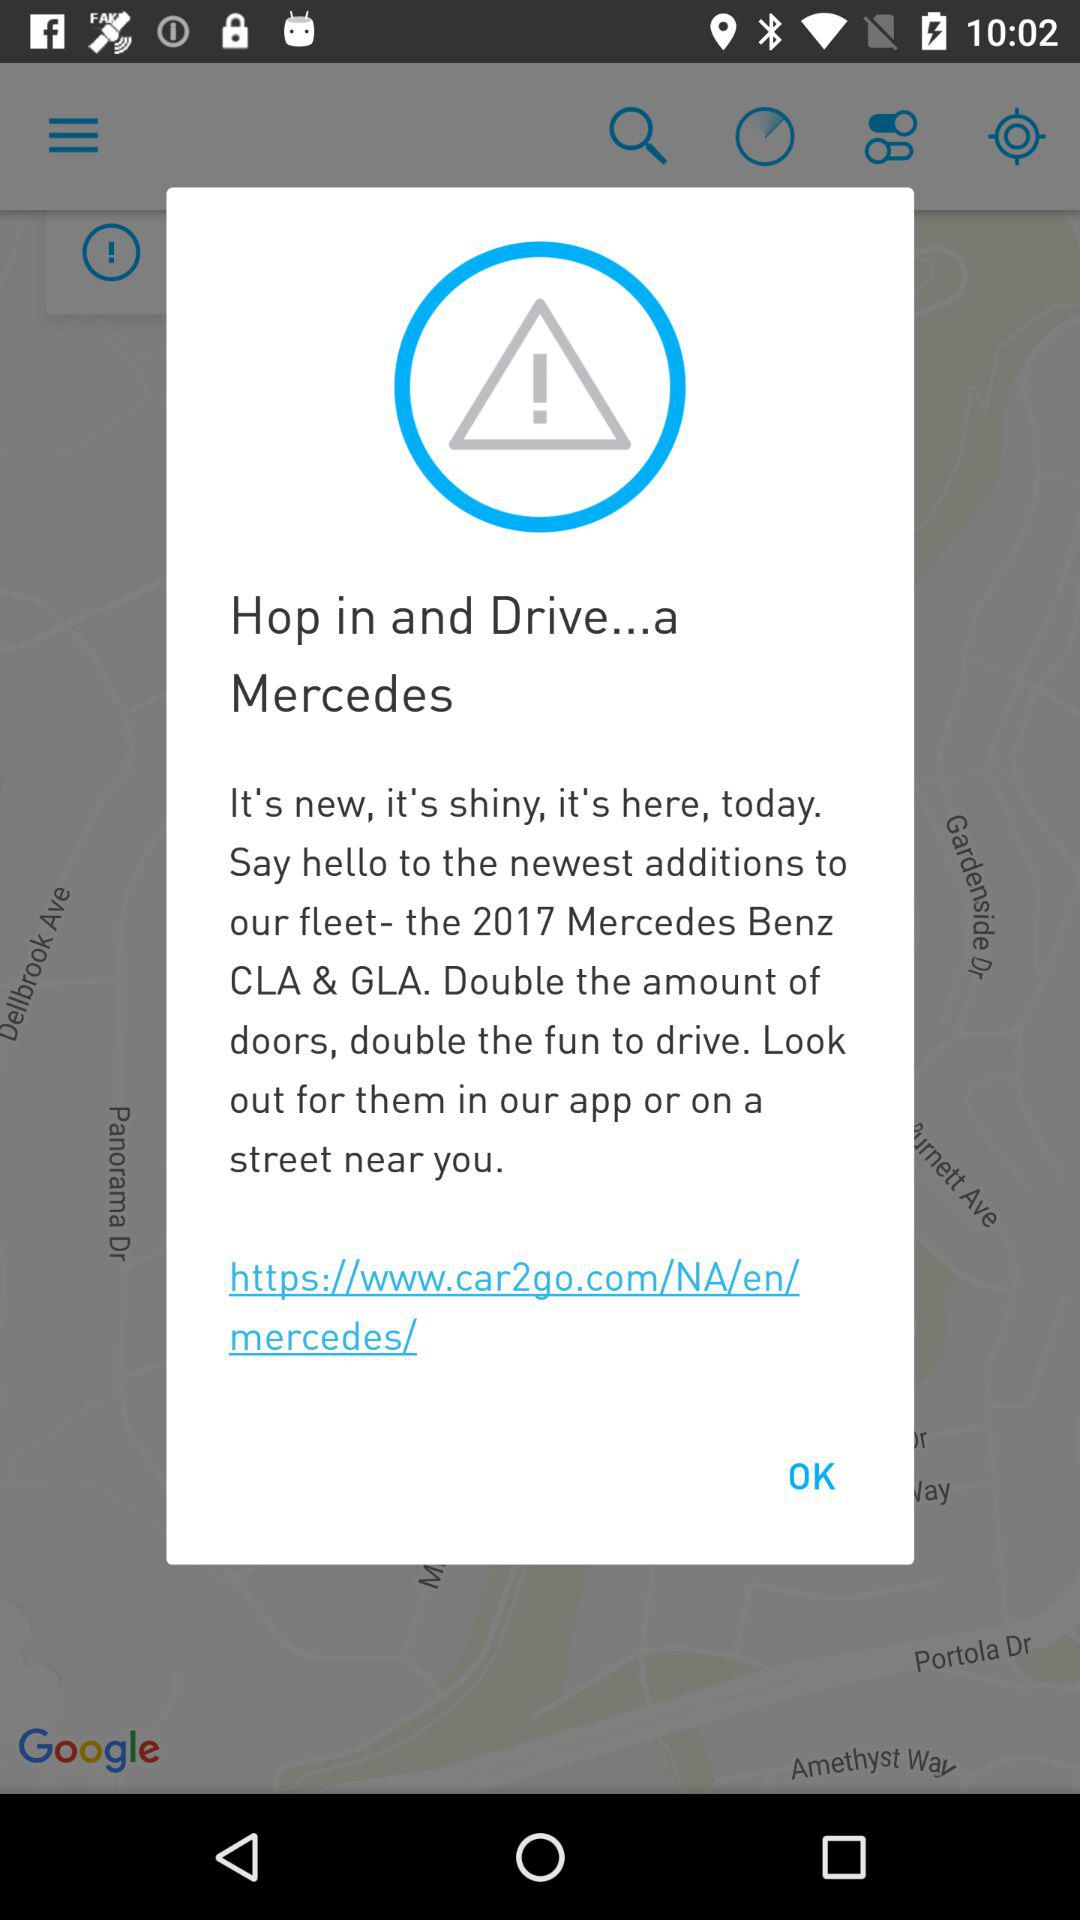How many Mercedes Benz models are in the fleet?
Answer the question using a single word or phrase. 2 